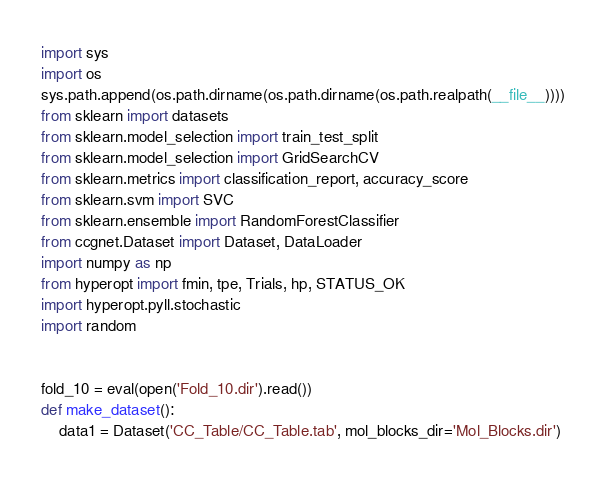<code> <loc_0><loc_0><loc_500><loc_500><_Python_>import sys
import os
sys.path.append(os.path.dirname(os.path.dirname(os.path.realpath(__file__))))
from sklearn import datasets
from sklearn.model_selection import train_test_split
from sklearn.model_selection import GridSearchCV
from sklearn.metrics import classification_report, accuracy_score
from sklearn.svm import SVC
from sklearn.ensemble import RandomForestClassifier
from ccgnet.Dataset import Dataset, DataLoader
import numpy as np
from hyperopt import fmin, tpe, Trials, hp, STATUS_OK
import hyperopt.pyll.stochastic
import random


fold_10 = eval(open('Fold_10.dir').read())
def make_dataset():
    data1 = Dataset('CC_Table/CC_Table.tab', mol_blocks_dir='Mol_Blocks.dir')</code> 